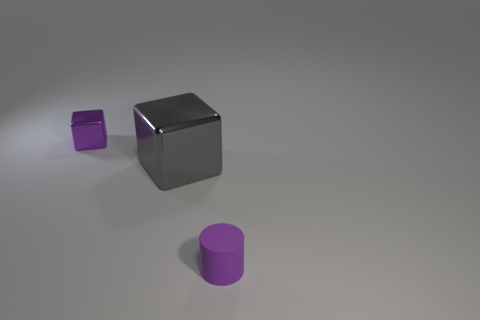Add 1 tiny purple objects. How many objects exist? 4 Subtract all gray cubes. How many cubes are left? 1 Subtract all gray blocks. Subtract all brown spheres. How many blocks are left? 1 Subtract all purple blocks. How many yellow cylinders are left? 0 Subtract all big blue things. Subtract all metal objects. How many objects are left? 1 Add 1 rubber objects. How many rubber objects are left? 2 Add 1 big gray metallic things. How many big gray metallic things exist? 2 Subtract 0 cyan blocks. How many objects are left? 3 Subtract all blocks. How many objects are left? 1 Subtract 1 cylinders. How many cylinders are left? 0 